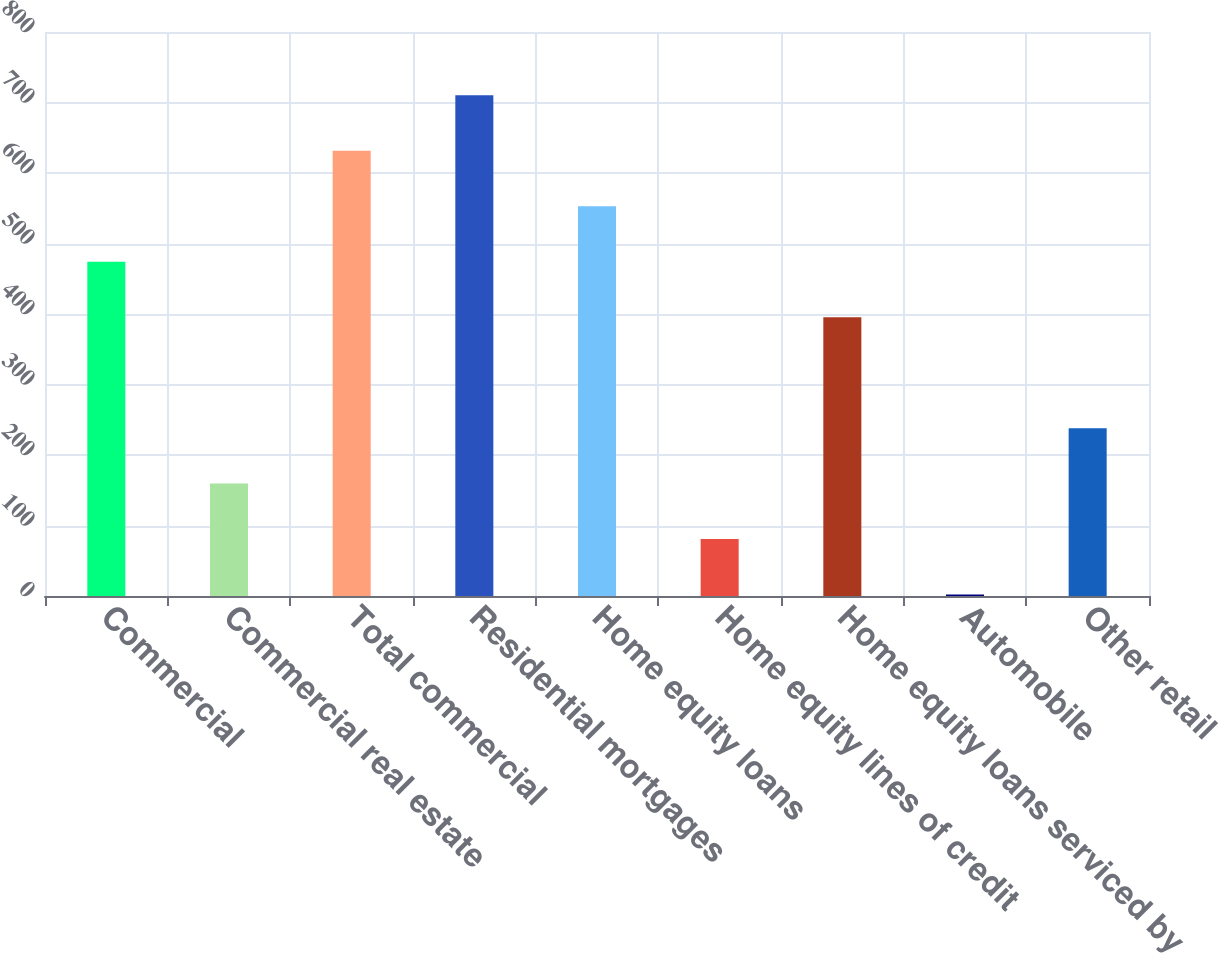Convert chart to OTSL. <chart><loc_0><loc_0><loc_500><loc_500><bar_chart><fcel>Commercial<fcel>Commercial real estate<fcel>Total commercial<fcel>Residential mortgages<fcel>Home equity loans<fcel>Home equity lines of credit<fcel>Home equity loans serviced by<fcel>Automobile<fcel>Other retail<nl><fcel>474.2<fcel>159.4<fcel>631.6<fcel>710.3<fcel>552.9<fcel>80.7<fcel>395.5<fcel>2<fcel>238.1<nl></chart> 